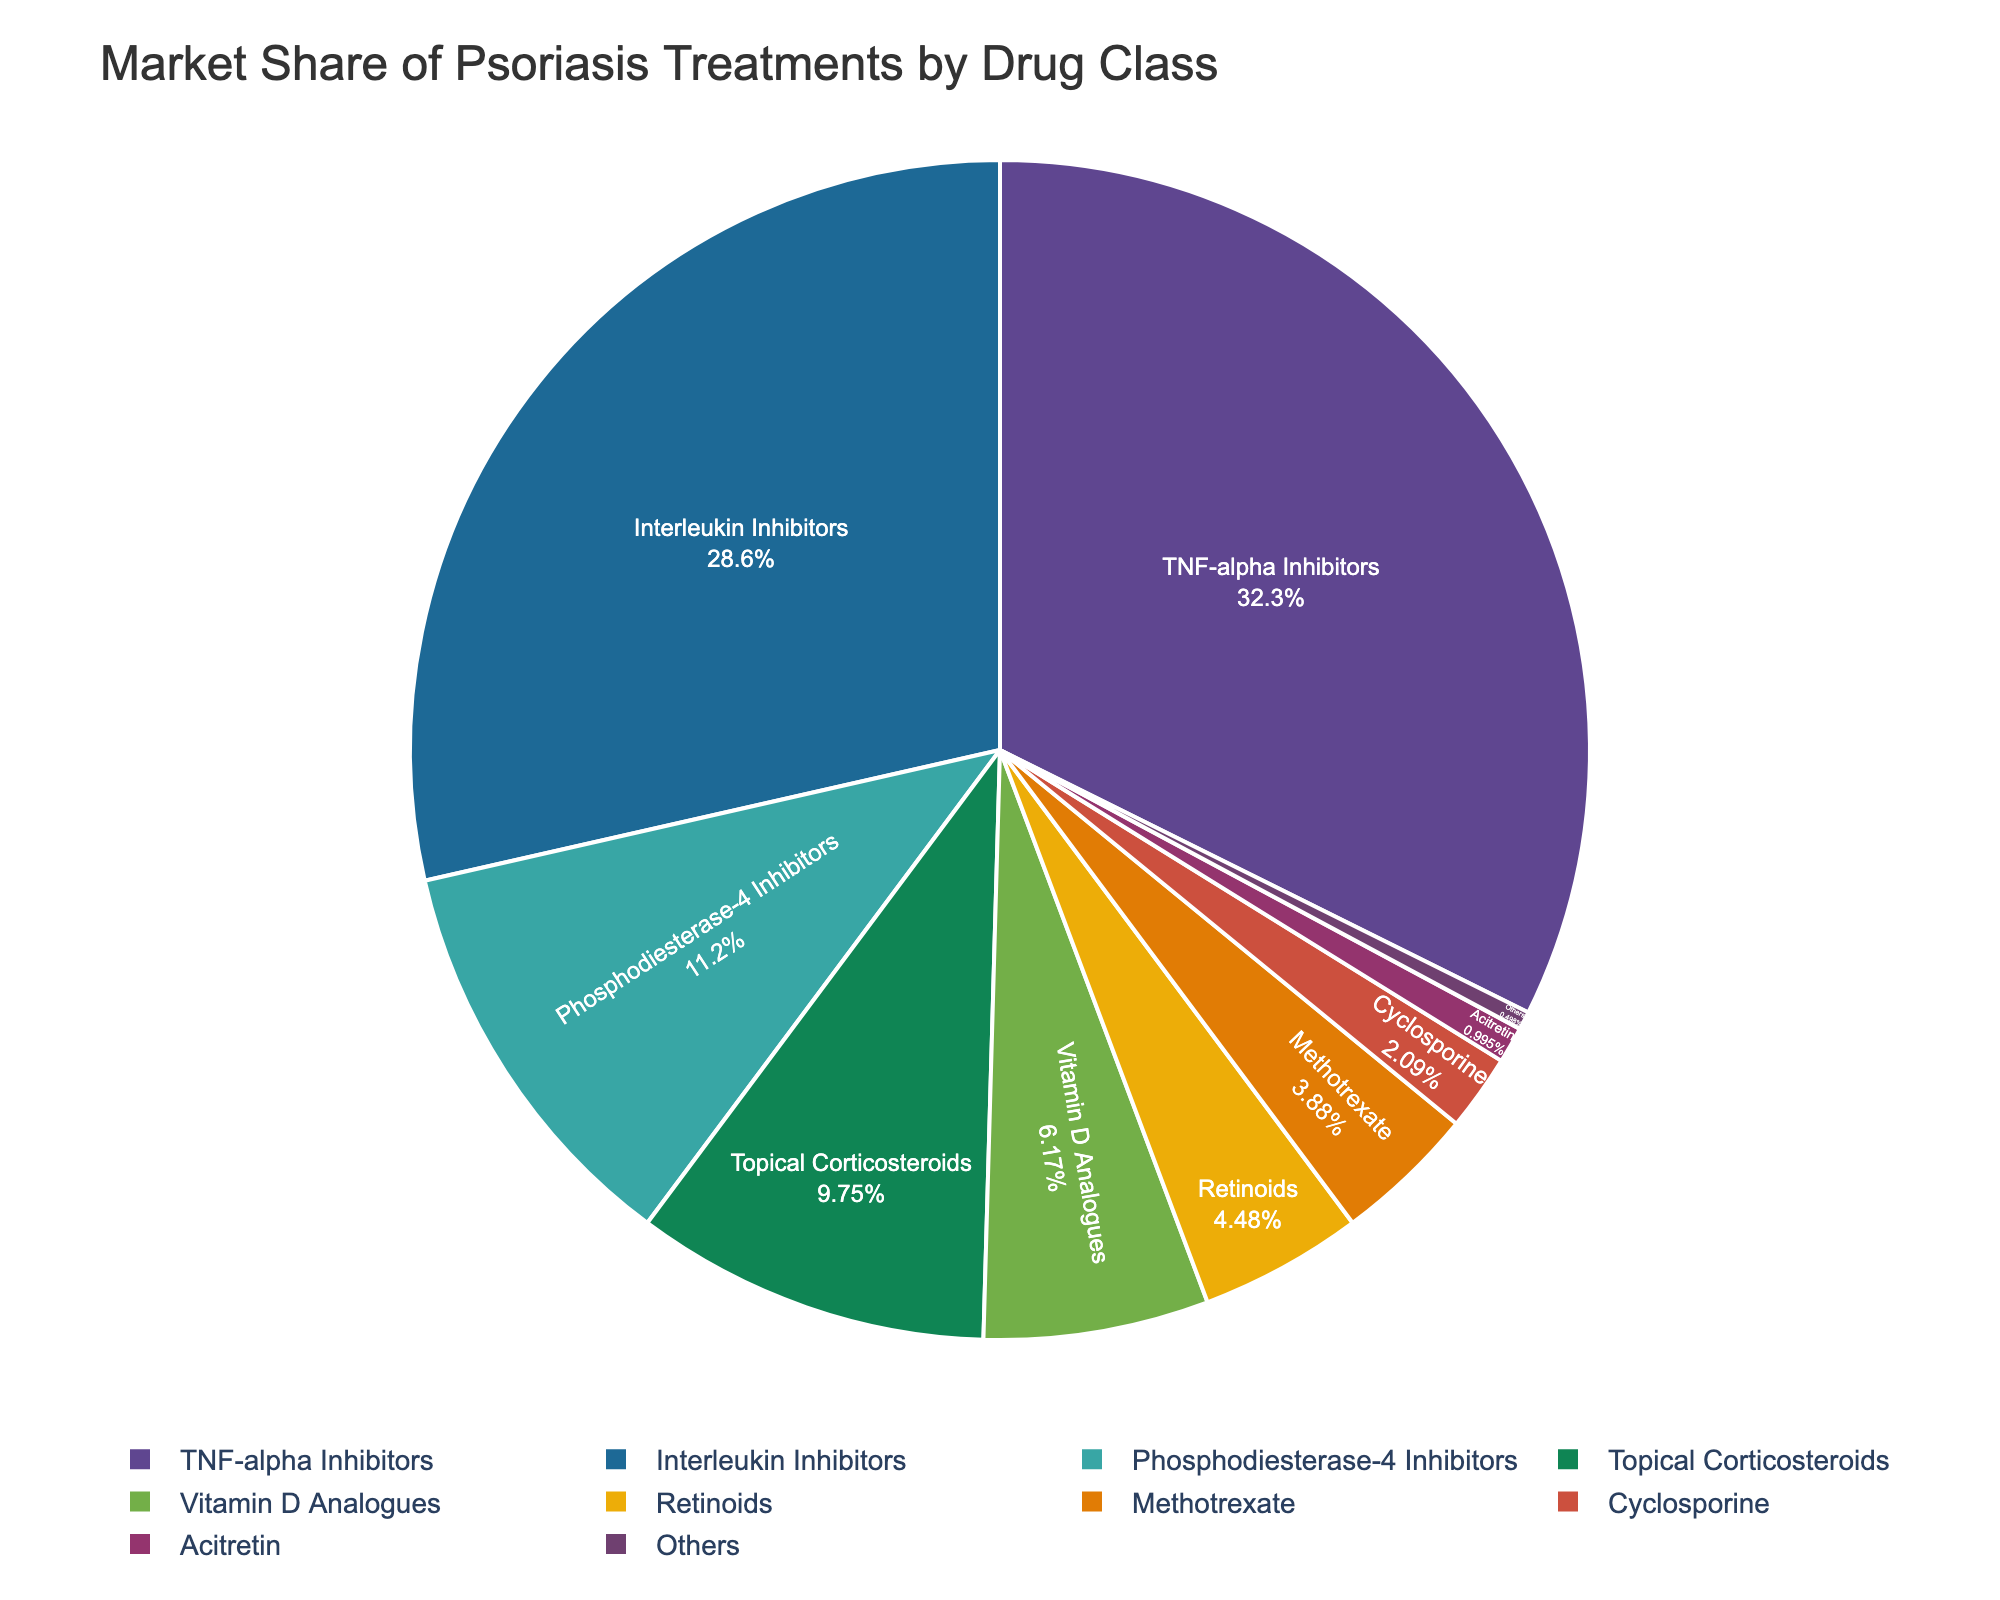what drug class has the highest market share? To find the highest market share, look at the figure and see which segment is the largest. The largest segment corresponds to TNF-alpha Inhibitors.
Answer: TNF-alpha Inhibitors Which drug classes have a combined market share greater than 50%? Adding the market shares of the top segments, TNF-alpha Inhibitors (32.5%) and Interleukin Inhibitors (28.7%), gives 61.2%, which is greater than 50%.
Answer: TNF-alpha Inhibitors and Interleukin Inhibitors What is the difference in market share between Interleukin Inhibitors and Phosphodiesterase-4 Inhibitors? Subtract the market share percentage of Phosphodiesterase-4 Inhibitors (11.3%) from Interleukin Inhibitors (28.7%). The difference is 28.7% - 11.3%.
Answer: 17.4% Rank the drug classes by market share percentage from highest to lowest? Arrange the drug classes based on their market share from the largest to smallest: TNF-alpha Inhibitors (32.5%), Interleukin Inhibitors (28.7%), Phosphodiesterase-4 Inhibitors (11.3%), Topical Corticosteroids (9.8%), Vitamin D Analogues (6.2%), Retinoids (4.5%), Methotrexate (3.9%), Cyclosporine (2.1%), Acitretin (1.0%), Others (0.5%).
Answer: TNF-alpha Inhibitors, Interleukin Inhibitors, Phosphodiesterase-4 Inhibitors, Topical Corticosteroids, Vitamin D Analogues, Retinoids, Methotrexate, Cyclosporine, Acitretin, Others If we combine the segments with less than 5% market share, what percentage of the market do they represent and which drug classes do they include? Add up the market share percentages of Retinoids (4.5%), Methotrexate (3.9%), Cyclosporine (2.1%), Acitretin (1.0%), and Others (0.5%). The total market share is 4.5% + 3.9% + 2.1% + 1.0% + 0.5% = 12.0%. The drug classes included are Retinoids, Methotrexate, Cyclosporine, Acitretin, and Others.
Answer: 12.0%, Retinoids, Methotrexate, Cyclosporine, Acitretin, Others Which drug classes individually account for less than 5% of the market? Look at each segment and identify those with market share percentages less than 5%. They are Retinoids (4.5%), Methotrexate (3.9%), Cyclosporine (2.1%), Acitretin (1.0%), and Others (0.5%).
Answer: Retinoids, Methotrexate, Cyclosporine, Acitretin, Others What proportion of the market does Topical Corticosteroids and Vitamin D Analogues occupy together? Add their market share percentages: Topical Corticosteroids (9.8%) and Vitamin D Analogues (6.2%). The total is 9.8% + 6.2%.
Answer: 16.0% How does the market share of Topical Corticosteroids compare to Vitamin D Analogues? Compare the market share percentages of the two classes: Topical Corticosteroids (9.8%) is greater than Vitamin D Analogues (6.2%).
Answer: Topical Corticosteroids has a greater market share If you were to combine Topical Corticosteroids, Vitamin D Analogues, and Retinoids, would their combined market share be more than that of TNF-alpha Inhibitors? Add their market share percentages: Topical Corticosteroids (9.8%) + Vitamin D Analogues (6.2%) + Retinoids (4.5%). The total is 9.8% + 6.2% + 4.5% = 20.5%, which is less than 32.5% (the market share of TNF-alpha Inhibitors).
Answer: No What is the combined market share of Phosphodiesterase-4 Inhibitors and Methotrexate? Add their market share percentages: Phosphodiesterase-4 Inhibitors (11.3%) and Methotrexate (3.9%). The total is 11.3% + 3.9% = 15.2%.
Answer: 15.2% 